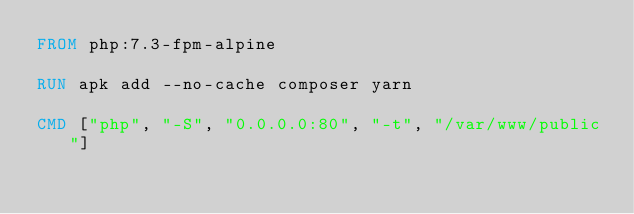<code> <loc_0><loc_0><loc_500><loc_500><_Dockerfile_>FROM php:7.3-fpm-alpine

RUN apk add --no-cache composer yarn

CMD ["php", "-S", "0.0.0.0:80", "-t", "/var/www/public"]
</code> 